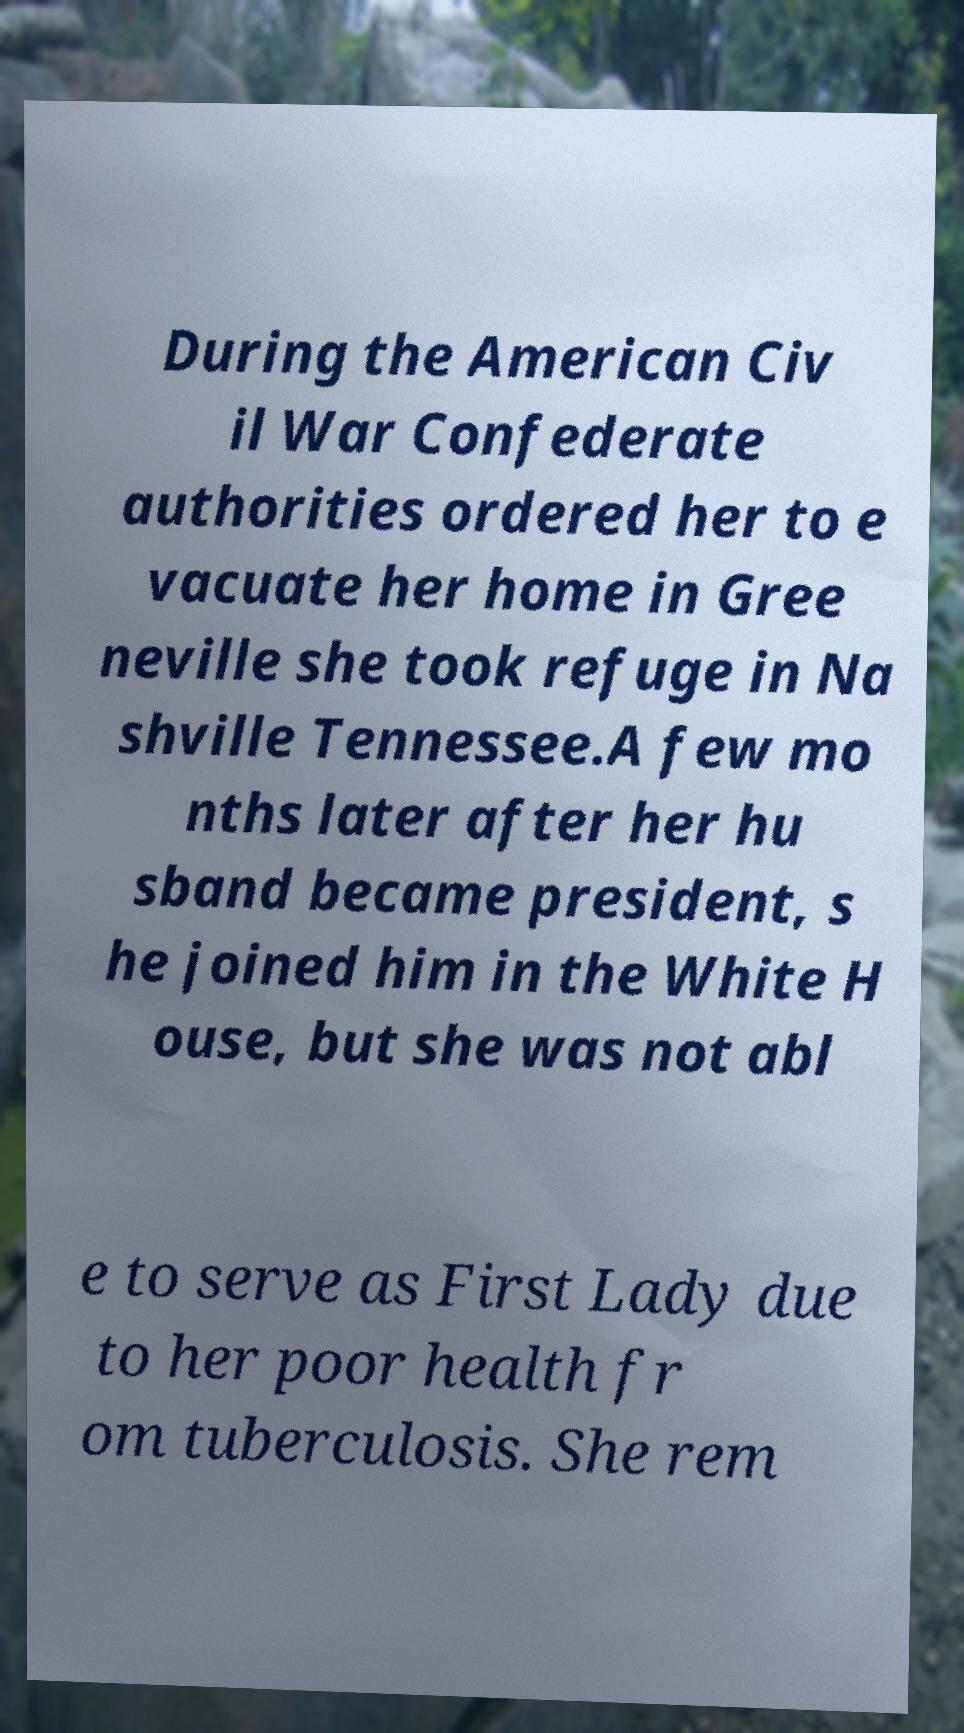Can you accurately transcribe the text from the provided image for me? During the American Civ il War Confederate authorities ordered her to e vacuate her home in Gree neville she took refuge in Na shville Tennessee.A few mo nths later after her hu sband became president, s he joined him in the White H ouse, but she was not abl e to serve as First Lady due to her poor health fr om tuberculosis. She rem 